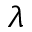Convert formula to latex. <formula><loc_0><loc_0><loc_500><loc_500>\lambda</formula> 